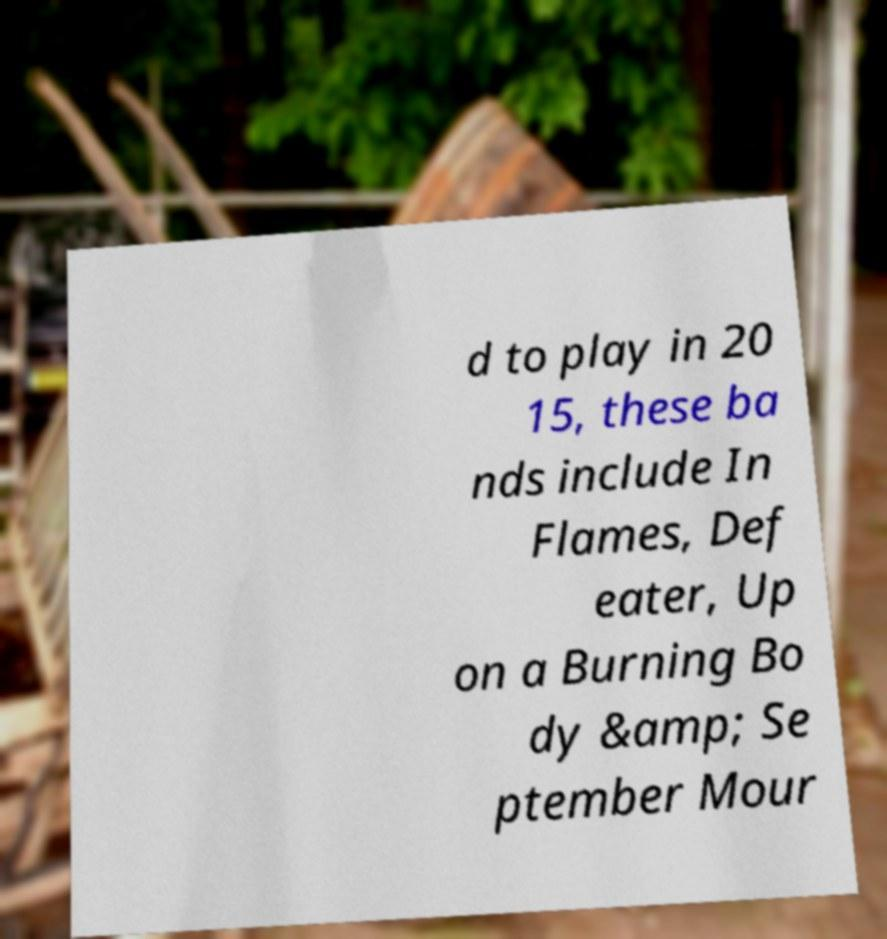What messages or text are displayed in this image? I need them in a readable, typed format. d to play in 20 15, these ba nds include In Flames, Def eater, Up on a Burning Bo dy &amp; Se ptember Mour 